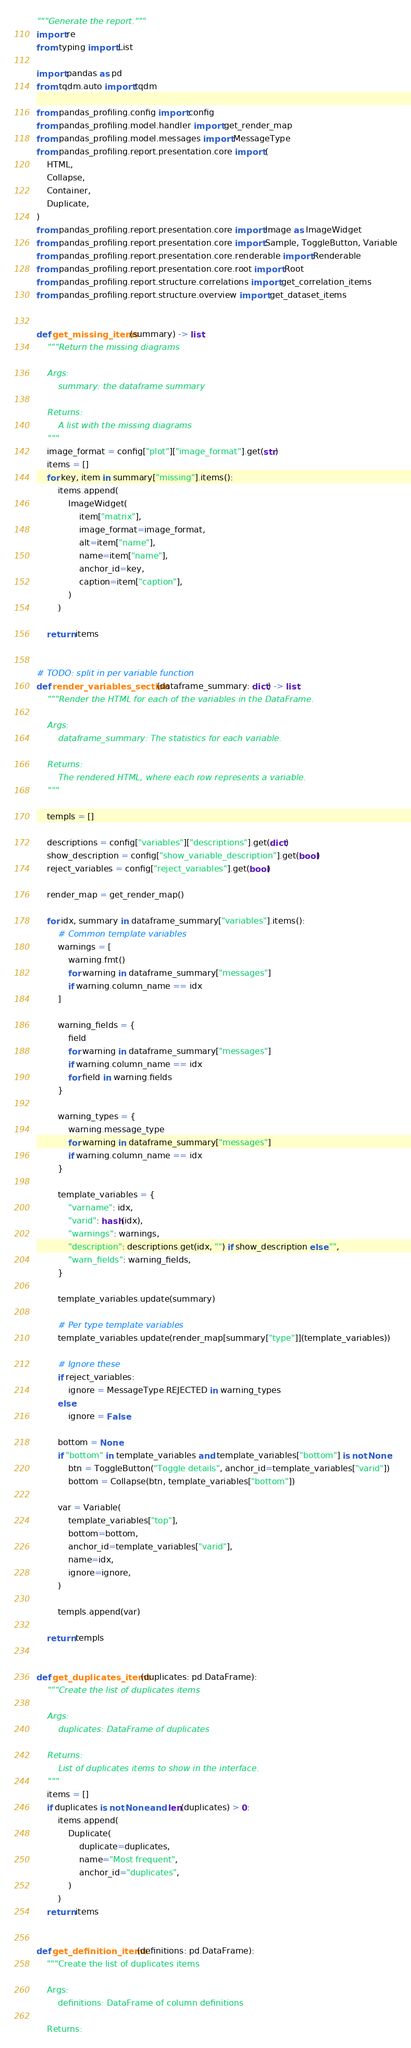<code> <loc_0><loc_0><loc_500><loc_500><_Python_>"""Generate the report."""
import re
from typing import List

import pandas as pd
from tqdm.auto import tqdm

from pandas_profiling.config import config
from pandas_profiling.model.handler import get_render_map
from pandas_profiling.model.messages import MessageType
from pandas_profiling.report.presentation.core import (
    HTML,
    Collapse,
    Container,
    Duplicate,
)
from pandas_profiling.report.presentation.core import Image as ImageWidget
from pandas_profiling.report.presentation.core import Sample, ToggleButton, Variable
from pandas_profiling.report.presentation.core.renderable import Renderable
from pandas_profiling.report.presentation.core.root import Root
from pandas_profiling.report.structure.correlations import get_correlation_items
from pandas_profiling.report.structure.overview import get_dataset_items


def get_missing_items(summary) -> list:
    """Return the missing diagrams

    Args:
        summary: the dataframe summary

    Returns:
        A list with the missing diagrams
    """
    image_format = config["plot"]["image_format"].get(str)
    items = []
    for key, item in summary["missing"].items():
        items.append(
            ImageWidget(
                item["matrix"],
                image_format=image_format,
                alt=item["name"],
                name=item["name"],
                anchor_id=key,
                caption=item["caption"],
            )
        )

    return items


# TODO: split in per variable function
def render_variables_section(dataframe_summary: dict) -> list:
    """Render the HTML for each of the variables in the DataFrame.

    Args:
        dataframe_summary: The statistics for each variable.

    Returns:
        The rendered HTML, where each row represents a variable.
    """

    templs = []

    descriptions = config["variables"]["descriptions"].get(dict)
    show_description = config["show_variable_description"].get(bool)
    reject_variables = config["reject_variables"].get(bool)

    render_map = get_render_map()

    for idx, summary in dataframe_summary["variables"].items():
        # Common template variables
        warnings = [
            warning.fmt()
            for warning in dataframe_summary["messages"]
            if warning.column_name == idx
        ]

        warning_fields = {
            field
            for warning in dataframe_summary["messages"]
            if warning.column_name == idx
            for field in warning.fields
        }

        warning_types = {
            warning.message_type
            for warning in dataframe_summary["messages"]
            if warning.column_name == idx
        }

        template_variables = {
            "varname": idx,
            "varid": hash(idx),
            "warnings": warnings,
            "description": descriptions.get(idx, "") if show_description else "",
            "warn_fields": warning_fields,
        }

        template_variables.update(summary)

        # Per type template variables
        template_variables.update(render_map[summary["type"]](template_variables))

        # Ignore these
        if reject_variables:
            ignore = MessageType.REJECTED in warning_types
        else:
            ignore = False

        bottom = None
        if "bottom" in template_variables and template_variables["bottom"] is not None:
            btn = ToggleButton("Toggle details", anchor_id=template_variables["varid"])
            bottom = Collapse(btn, template_variables["bottom"])

        var = Variable(
            template_variables["top"],
            bottom=bottom,
            anchor_id=template_variables["varid"],
            name=idx,
            ignore=ignore,
        )

        templs.append(var)

    return templs


def get_duplicates_items(duplicates: pd.DataFrame):
    """Create the list of duplicates items

    Args:
        duplicates: DataFrame of duplicates

    Returns:
        List of duplicates items to show in the interface.
    """
    items = []
    if duplicates is not None and len(duplicates) > 0:
        items.append(
            Duplicate(
                duplicate=duplicates,
                name="Most frequent",
                anchor_id="duplicates",
            )
        )
    return items


def get_definition_items(definitions: pd.DataFrame):
    """Create the list of duplicates items

    Args:
        definitions: DataFrame of column definitions

    Returns:</code> 